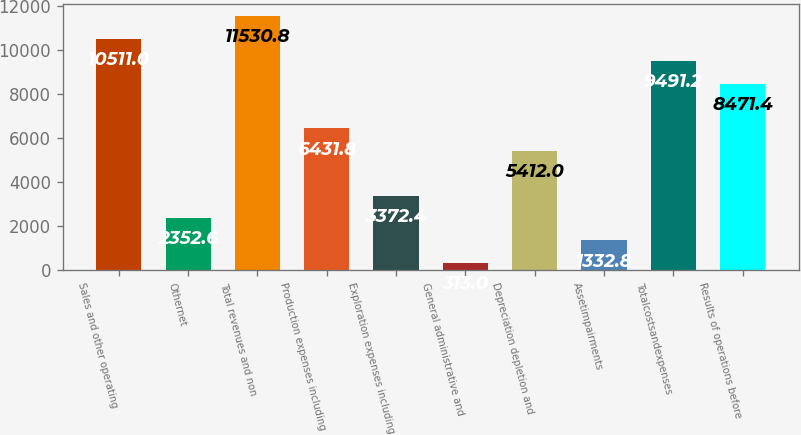<chart> <loc_0><loc_0><loc_500><loc_500><bar_chart><fcel>Sales and other operating<fcel>Othernet<fcel>Total revenues and non<fcel>Production expenses including<fcel>Exploration expenses including<fcel>General administrative and<fcel>Depreciation depletion and<fcel>Assetimpairments<fcel>Totalcostsandexpenses<fcel>Results of operations before<nl><fcel>10511<fcel>2352.6<fcel>11530.8<fcel>6431.8<fcel>3372.4<fcel>313<fcel>5412<fcel>1332.8<fcel>9491.2<fcel>8471.4<nl></chart> 